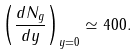<formula> <loc_0><loc_0><loc_500><loc_500>\left ( \frac { d N _ { g } } { d y } \right ) _ { y = 0 } \simeq 4 0 0 .</formula> 